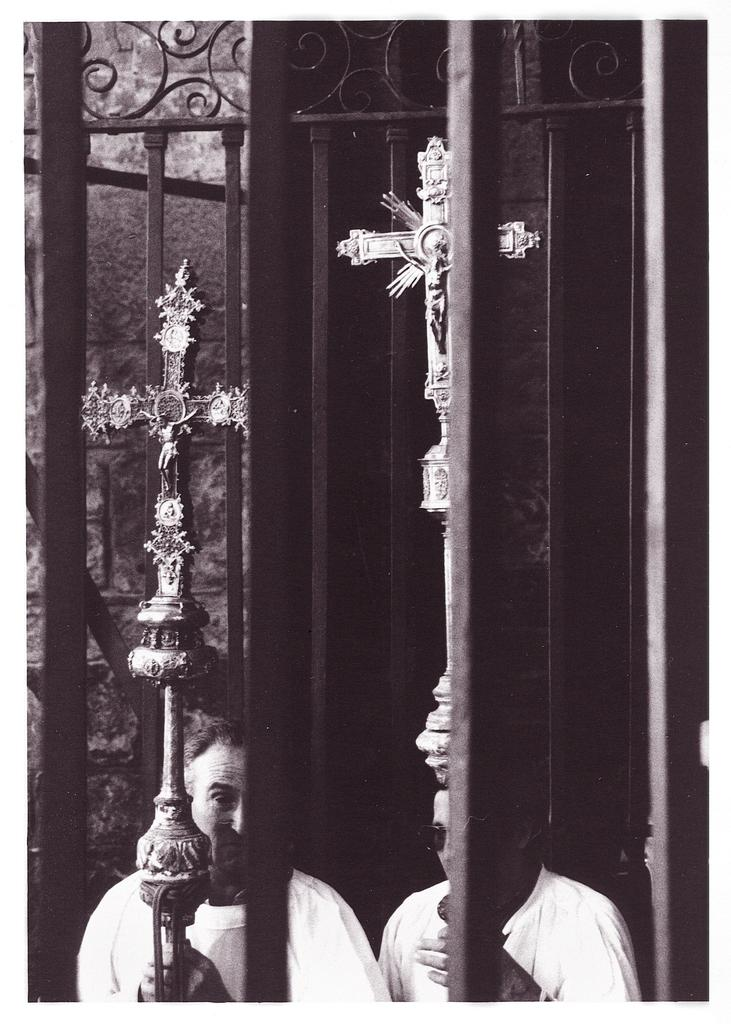How many people are in the image? There are two persons in the image. What are the persons holding in the image? The persons are holding objects. What type of barrier can be seen in the image? There is a fence in the image. What can be seen in the background of the image? There is a wall visible in the background of the image. What statement can be heard being made by the persons in the image? There is no dialogue or statement present in the image, as it is a still photograph. 